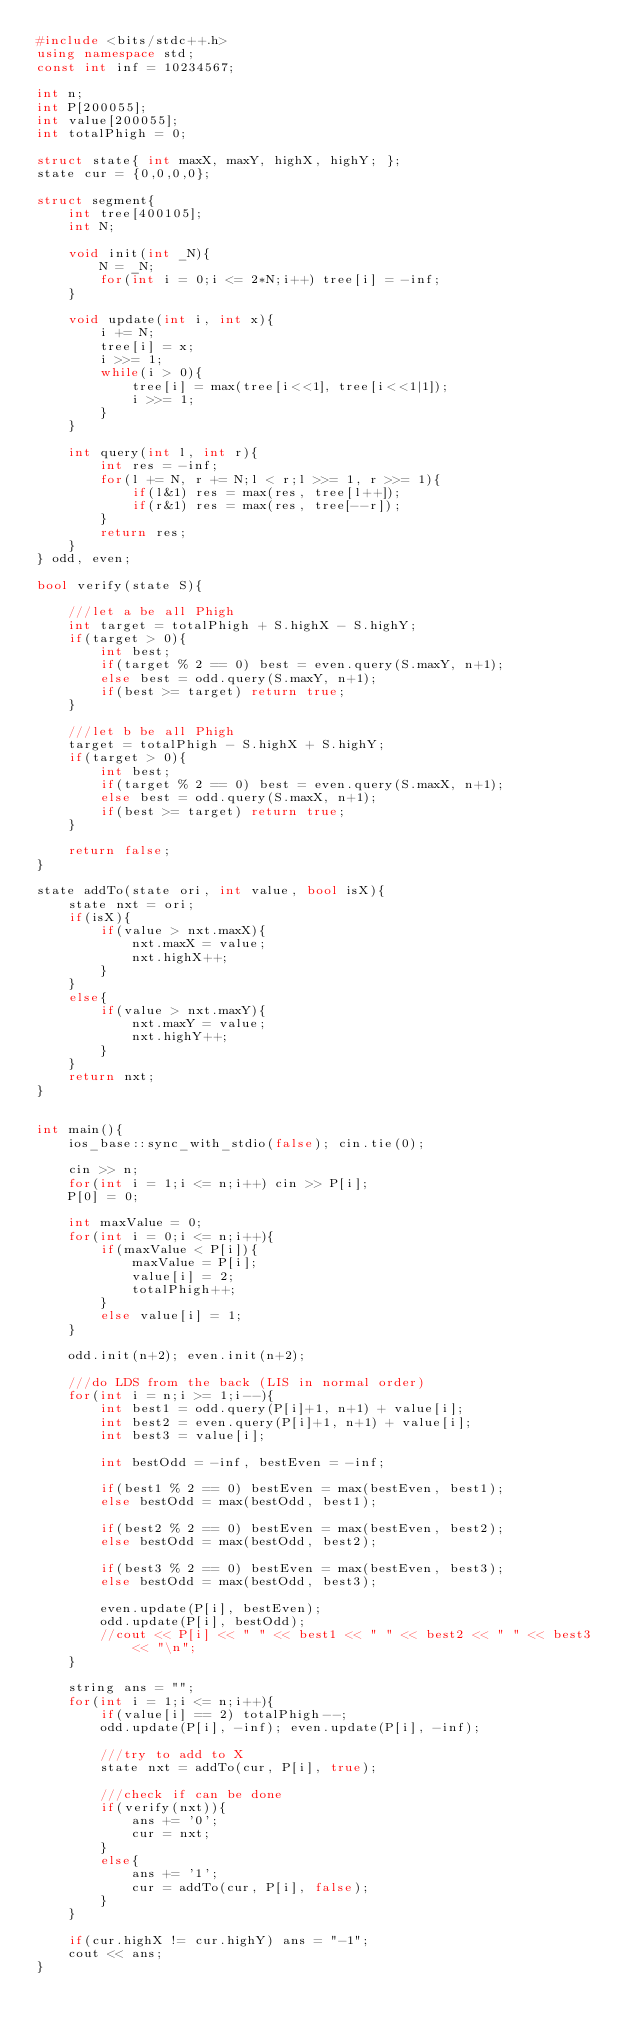<code> <loc_0><loc_0><loc_500><loc_500><_C++_>#include <bits/stdc++.h>
using namespace std;
const int inf = 10234567;

int n; 
int P[200055];
int value[200055];
int totalPhigh = 0;

struct state{ int maxX, maxY, highX, highY; };
state cur = {0,0,0,0};

struct segment{
	int tree[400105];
	int N;
	
	void init(int _N){
		N = _N;
		for(int i = 0;i <= 2*N;i++) tree[i] = -inf;
	}
	
	void update(int i, int x){
		i += N;
		tree[i] = x;
		i >>= 1;
		while(i > 0){
			tree[i] = max(tree[i<<1], tree[i<<1|1]);
			i >>= 1;
		}
	}
	
	int query(int l, int r){
		int res = -inf;
		for(l += N, r += N;l < r;l >>= 1, r >>= 1){
			if(l&1) res = max(res, tree[l++]);
			if(r&1) res = max(res, tree[--r]);
		}
		return res;
	}
} odd, even;

bool verify(state S){
	
	///let a be all Phigh
	int target = totalPhigh + S.highX - S.highY;
	if(target > 0){
		int best;
		if(target % 2 == 0) best = even.query(S.maxY, n+1);
		else best = odd.query(S.maxY, n+1);
		if(best >= target) return true;
	}
	
	///let b be all Phigh
	target = totalPhigh - S.highX + S.highY;
	if(target > 0){
		int best;
		if(target % 2 == 0) best = even.query(S.maxX, n+1);
		else best = odd.query(S.maxX, n+1);
		if(best >= target) return true;
	}
	
	return false;
}

state addTo(state ori, int value, bool isX){
	state nxt = ori;
	if(isX){
		if(value > nxt.maxX){
			nxt.maxX = value;
			nxt.highX++;
		}
	}
	else{
		if(value > nxt.maxY){
			nxt.maxY = value;
			nxt.highY++;
		}
	}
	return nxt;
}

	
int main(){
	ios_base::sync_with_stdio(false); cin.tie(0);
	
	cin >> n;
	for(int i = 1;i <= n;i++) cin >> P[i];
	P[0] = 0;
	
	int maxValue = 0;
	for(int i = 0;i <= n;i++){
		if(maxValue < P[i]){
			maxValue = P[i];
			value[i] = 2;
			totalPhigh++;
		}
		else value[i] = 1;
	}
	
	odd.init(n+2); even.init(n+2);
	
	///do LDS from the back (LIS in normal order)
	for(int i = n;i >= 1;i--){
		int best1 = odd.query(P[i]+1, n+1) + value[i];
		int best2 = even.query(P[i]+1, n+1) + value[i];
		int best3 = value[i];
		
		int bestOdd = -inf, bestEven = -inf;
		
		if(best1 % 2 == 0) bestEven = max(bestEven, best1);
		else bestOdd = max(bestOdd, best1);
		
		if(best2 % 2 == 0) bestEven = max(bestEven, best2);
		else bestOdd = max(bestOdd, best2);
		
		if(best3 % 2 == 0) bestEven = max(bestEven, best3);
		else bestOdd = max(bestOdd, best3);
		
		even.update(P[i], bestEven);
		odd.update(P[i], bestOdd);
		//cout << P[i] << " " << best1 << " " << best2 << " " << best3 << "\n";
	}
		
	string ans = "";
	for(int i = 1;i <= n;i++){
		if(value[i] == 2) totalPhigh--;
		odd.update(P[i], -inf); even.update(P[i], -inf);
		
		///try to add to X
		state nxt = addTo(cur, P[i], true);
		
		///check if can be done
		if(verify(nxt)){
			ans += '0';
			cur = nxt;
		}
		else{
			ans += '1';
			cur = addTo(cur, P[i], false);
		}
	}
	
	if(cur.highX != cur.highY) ans = "-1";
	cout << ans;
}
</code> 